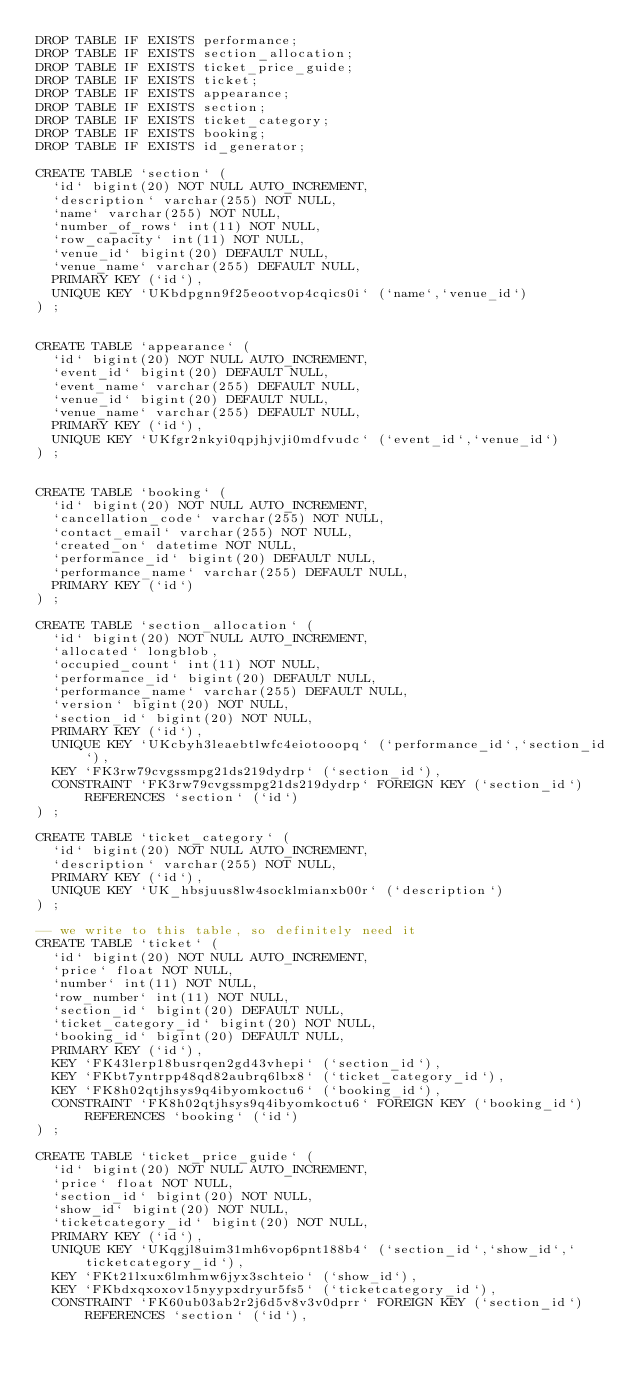Convert code to text. <code><loc_0><loc_0><loc_500><loc_500><_SQL_>DROP TABLE IF EXISTS performance;
DROP TABLE IF EXISTS section_allocation;
DROP TABLE IF EXISTS ticket_price_guide;
DROP TABLE IF EXISTS ticket;
DROP TABLE IF EXISTS appearance;
DROP TABLE IF EXISTS section;
DROP TABLE IF EXISTS ticket_category;
DROP TABLE IF EXISTS booking;
DROP TABLE IF EXISTS id_generator;

CREATE TABLE `section` (
  `id` bigint(20) NOT NULL AUTO_INCREMENT,
  `description` varchar(255) NOT NULL,
  `name` varchar(255) NOT NULL,
  `number_of_rows` int(11) NOT NULL,
  `row_capacity` int(11) NOT NULL,
  `venue_id` bigint(20) DEFAULT NULL,
  `venue_name` varchar(255) DEFAULT NULL,
  PRIMARY KEY (`id`),
  UNIQUE KEY `UKbdpgnn9f25eootvop4cqics0i` (`name`,`venue_id`)
) ;


CREATE TABLE `appearance` (
  `id` bigint(20) NOT NULL AUTO_INCREMENT,
  `event_id` bigint(20) DEFAULT NULL,
  `event_name` varchar(255) DEFAULT NULL,
  `venue_id` bigint(20) DEFAULT NULL,
  `venue_name` varchar(255) DEFAULT NULL,
  PRIMARY KEY (`id`),
  UNIQUE KEY `UKfgr2nkyi0qpjhjvji0mdfvudc` (`event_id`,`venue_id`)
) ;


CREATE TABLE `booking` (
  `id` bigint(20) NOT NULL AUTO_INCREMENT,
  `cancellation_code` varchar(255) NOT NULL,
  `contact_email` varchar(255) NOT NULL,
  `created_on` datetime NOT NULL,
  `performance_id` bigint(20) DEFAULT NULL,
  `performance_name` varchar(255) DEFAULT NULL,
  PRIMARY KEY (`id`)
) ;

CREATE TABLE `section_allocation` (
  `id` bigint(20) NOT NULL AUTO_INCREMENT,
  `allocated` longblob,
  `occupied_count` int(11) NOT NULL,
  `performance_id` bigint(20) DEFAULT NULL,
  `performance_name` varchar(255) DEFAULT NULL,
  `version` bigint(20) NOT NULL,
  `section_id` bigint(20) NOT NULL,
  PRIMARY KEY (`id`),
  UNIQUE KEY `UKcbyh3leaebtlwfc4eiotooopq` (`performance_id`,`section_id`),
  KEY `FK3rw79cvgssmpg21ds219dydrp` (`section_id`),
  CONSTRAINT `FK3rw79cvgssmpg21ds219dydrp` FOREIGN KEY (`section_id`) REFERENCES `section` (`id`)
) ;

CREATE TABLE `ticket_category` (
  `id` bigint(20) NOT NULL AUTO_INCREMENT,
  `description` varchar(255) NOT NULL,
  PRIMARY KEY (`id`),
  UNIQUE KEY `UK_hbsjuus8lw4socklmianxb00r` (`description`)
) ;

-- we write to this table, so definitely need it
CREATE TABLE `ticket` (
  `id` bigint(20) NOT NULL AUTO_INCREMENT,
  `price` float NOT NULL,
  `number` int(11) NOT NULL,
  `row_number` int(11) NOT NULL,
  `section_id` bigint(20) DEFAULT NULL,
  `ticket_category_id` bigint(20) NOT NULL,
  `booking_id` bigint(20) DEFAULT NULL,
  PRIMARY KEY (`id`),
  KEY `FK43lerp18busrqen2gd43vhepi` (`section_id`),
  KEY `FKbt7yntrpp48qd82aubrq6lbx8` (`ticket_category_id`),
  KEY `FK8h02qtjhsys9q4ibyomkoctu6` (`booking_id`),
  CONSTRAINT `FK8h02qtjhsys9q4ibyomkoctu6` FOREIGN KEY (`booking_id`) REFERENCES `booking` (`id`)
) ;

CREATE TABLE `ticket_price_guide` (
  `id` bigint(20) NOT NULL AUTO_INCREMENT,
  `price` float NOT NULL,
  `section_id` bigint(20) NOT NULL,
  `show_id` bigint(20) NOT NULL,
  `ticketcategory_id` bigint(20) NOT NULL,
  PRIMARY KEY (`id`),
  UNIQUE KEY `UKqgjl8uim31mh6vop6pnt188b4` (`section_id`,`show_id`,`ticketcategory_id`),
  KEY `FKt21lxux6lmhmw6jyx3schteio` (`show_id`),
  KEY `FKbdxqxoxov15nyypxdryur5fs5` (`ticketcategory_id`),
  CONSTRAINT `FK60ub03ab2r2j6d5v8v3v0dprr` FOREIGN KEY (`section_id`) REFERENCES `section` (`id`),</code> 